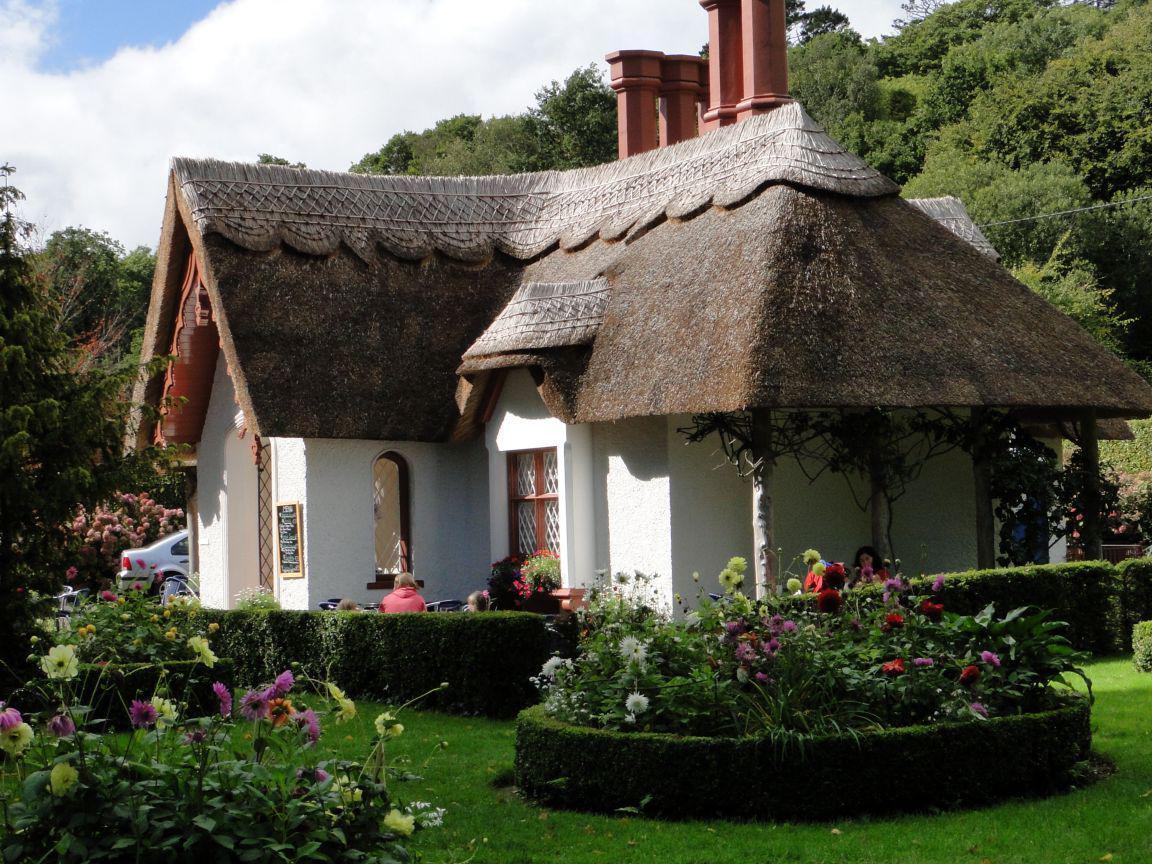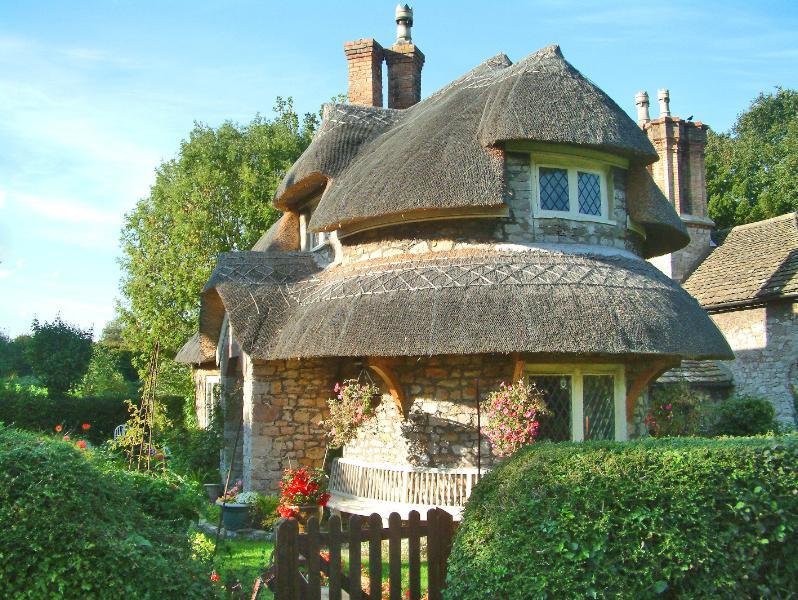The first image is the image on the left, the second image is the image on the right. Assess this claim about the two images: "The house on the left is behind a fence.". Correct or not? Answer yes or no. No. The first image is the image on the left, the second image is the image on the right. Considering the images on both sides, is "One roof is partly supported by posts." valid? Answer yes or no. Yes. 